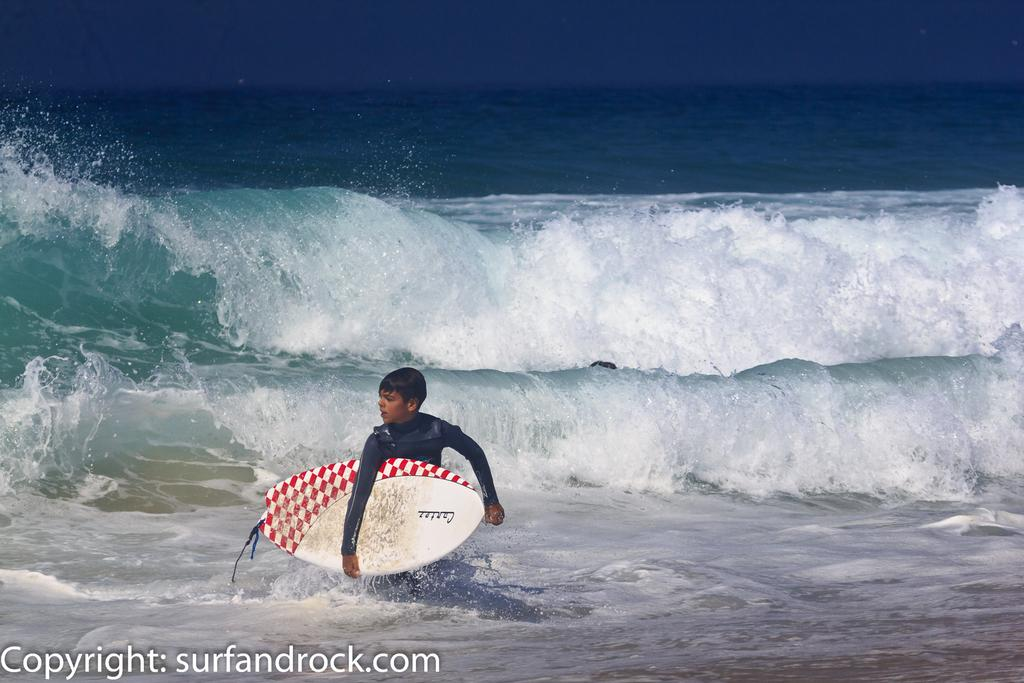What type of water body is present in the image? There is a fresh water river in the image. What can be observed about the river's movement? The river has waves. What is the man in the image doing? The man is standing in the water. What object is the man holding in the image? The man is holding a surfboard. What type of oatmeal is being prepared near the river in the image? There is no oatmeal present in the image, nor is there any indication of food preparation. 